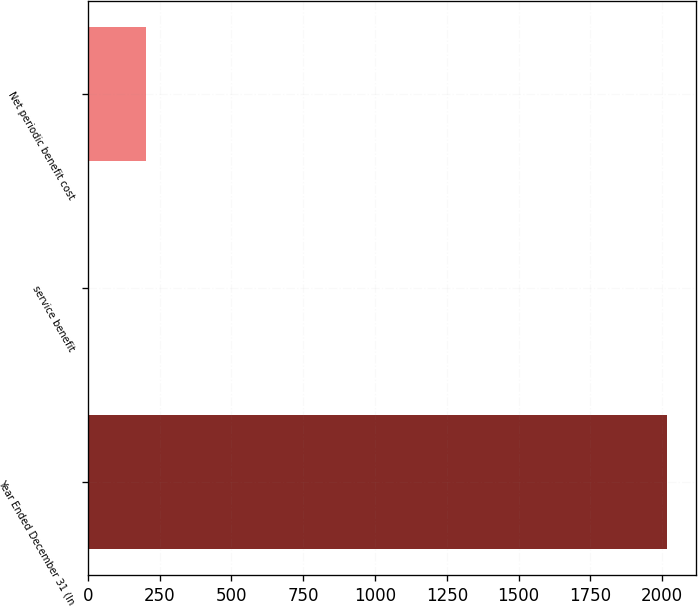Convert chart. <chart><loc_0><loc_0><loc_500><loc_500><bar_chart><fcel>Year Ended December 31 (In<fcel>service benefit<fcel>Net periodic benefit cost<nl><fcel>2016<fcel>3<fcel>204.3<nl></chart> 